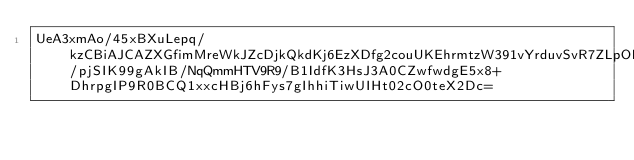Convert code to text. <code><loc_0><loc_0><loc_500><loc_500><_SML_>UeA3xmAo/45xBXuLepq/kzCBiAJCAZXGfimMreWkJZcDjkQkdKj6EzXDfg2couUKEhrmtzW391vYrduvSvR7ZLpOPOR4U5AHimOZvCTNZ98/pjSIK99gAkIB/NqQmmHTV9R9/B1IdfK3HsJ3A0CZwfwdgE5x8+DhrpgIP9R0BCQ1xxcHBj6hFys7gIhhiTiwUIHt02cO0teX2Dc=</code> 